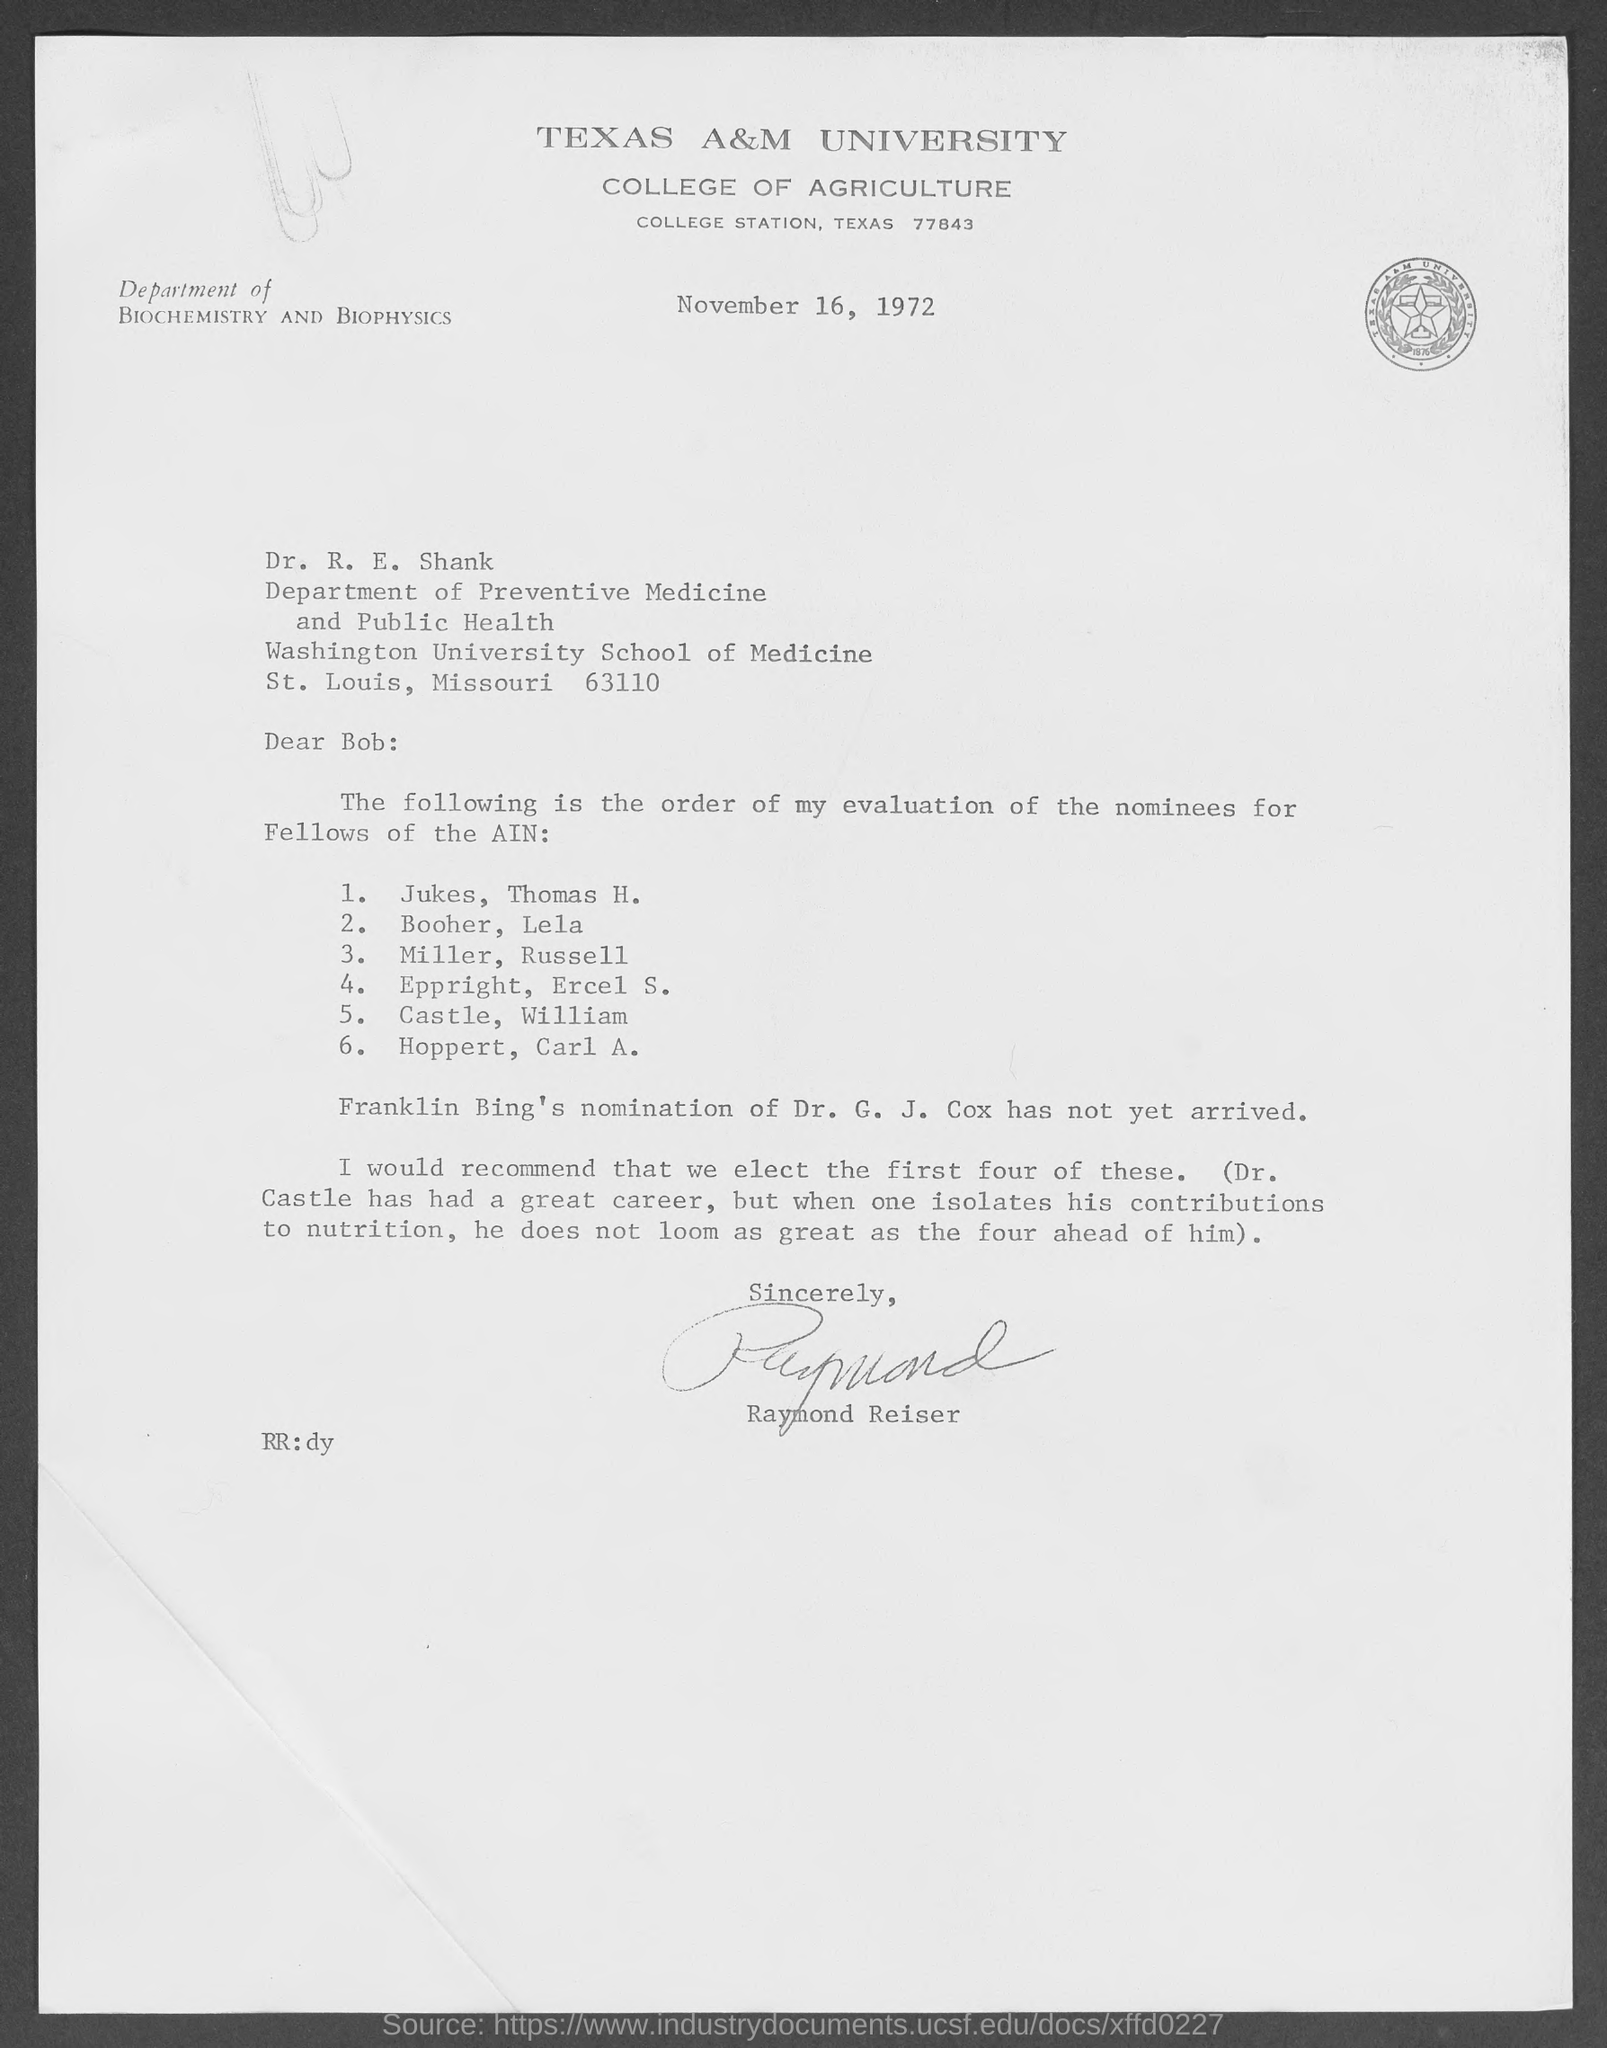Point out several critical features in this image. The date is November 16, 1972. The salutation of the letter is "Dear Bob: 